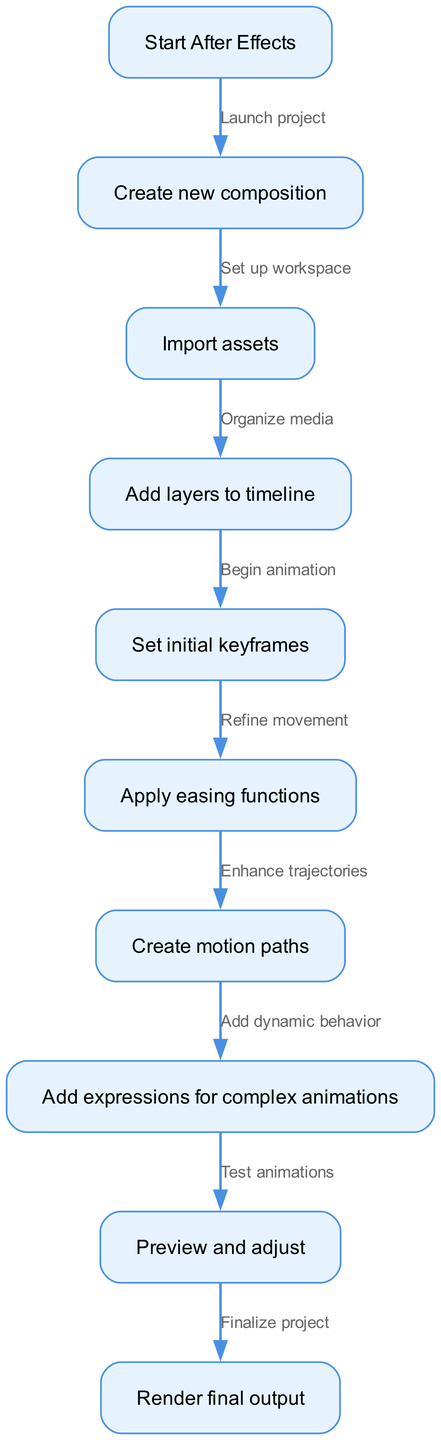What is the first step in the animation process? The diagram indicates that the first step is to "Start After Effects." This is represented by the initial node labeled "Start After Effects," showing the beginning of the process.
Answer: Start After Effects How many nodes are in the diagram? By counting the individual nodes listed in the data, there are a total of 10 nodes present in the diagram. This includes all distinct steps in the animation process.
Answer: 10 What is the output of the "Preview and adjust" step? The output of this step leads directly to the "Render final output" step, indicating that after previewing and making adjustments, the project moves towards finalization.
Answer: Render final output Which step directly follows "Set initial keyframes"? According to the flowchart, the step that directly follows "Set initial keyframes" is "Apply easing functions." The edge connecting these two nodes indicates the order of operations in the process.
Answer: Apply easing functions What action is taken after "Add dynamic behavior"? Following the "Add dynamic behavior" step, the next action is to "Preview and adjust." This implies that after adding expressions, the user should test the animations before proceeding.
Answer: Preview and adjust What does "Enhance trajectories" lead to? The action "Enhance trajectories," which corresponds to the step "Create motion paths," leads directly to "Add expressions for complex animations." This indicates a progression towards more advanced animation techniques.
Answer: Add expressions for complex animations What are the two primary functions of keyframes in this flowchart? The two primary functions of keyframes in this flowchart are to "Set initial keyframes" and to "Refine movement" through the use of easing functions, demonstrating the importance of keyframes in establishing animation motion and smoothness.
Answer: Set initial keyframes, Refine movement How many edges are displayed in the flowchart? By analyzing the edges connecting the nodes, it's clear there are 9 edges shown in the diagram, signifying each directional link between the steps in the workflow.
Answer: 9 What is the transition from "Begin animation" to "Apply easing functions"? The transition represents a crucial refinement step where after beginning the animation sequence, easing functions are applied to enhance the natural flow of movement, helping to make animations feel more organic and dynamic.
Answer: Apply easing functions 